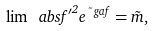Convert formula to latex. <formula><loc_0><loc_0><loc_500><loc_500>\lim \ a b s { f ^ { \prime } } ^ { 2 } e ^ { \tilde { \ } g a f } = \tilde { m } ,</formula> 